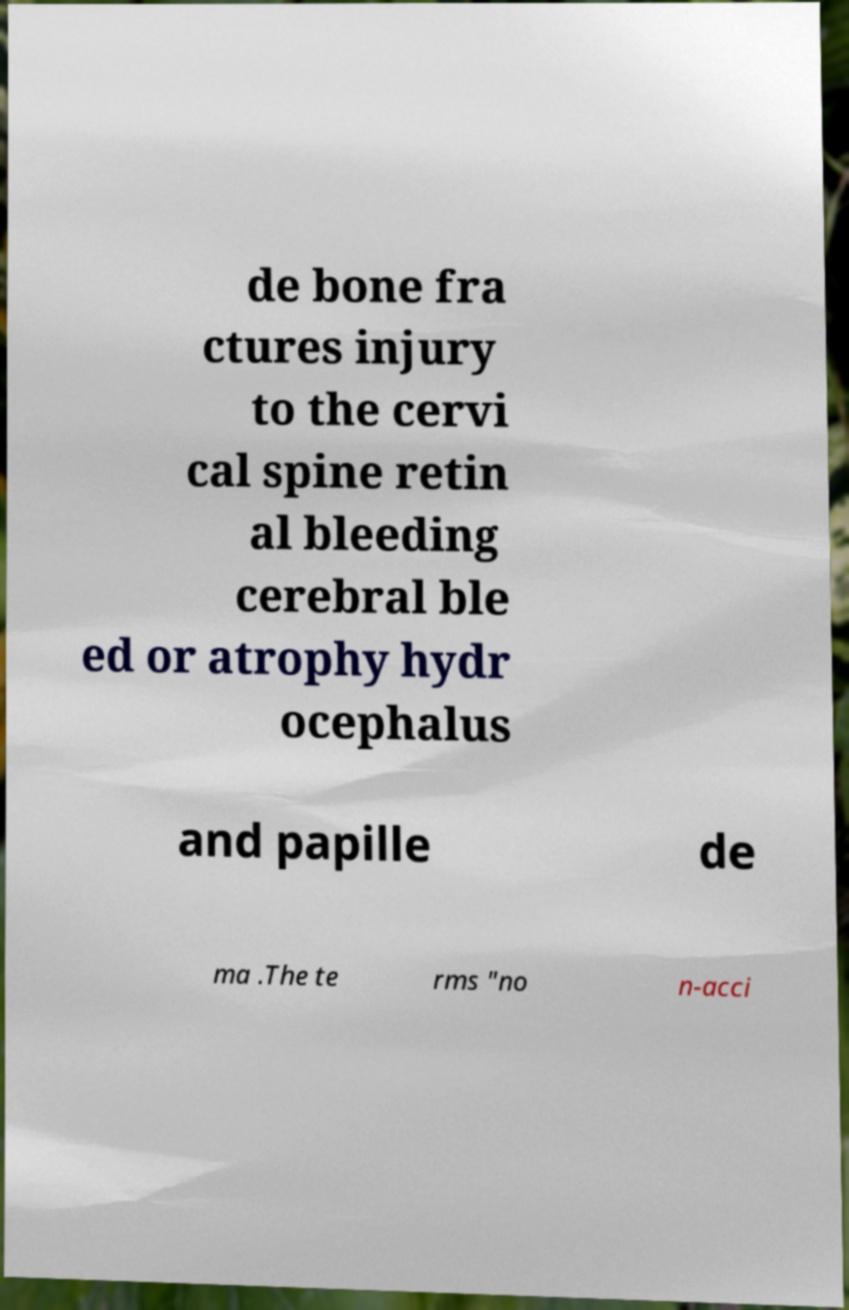Can you accurately transcribe the text from the provided image for me? de bone fra ctures injury to the cervi cal spine retin al bleeding cerebral ble ed or atrophy hydr ocephalus and papille de ma .The te rms "no n-acci 